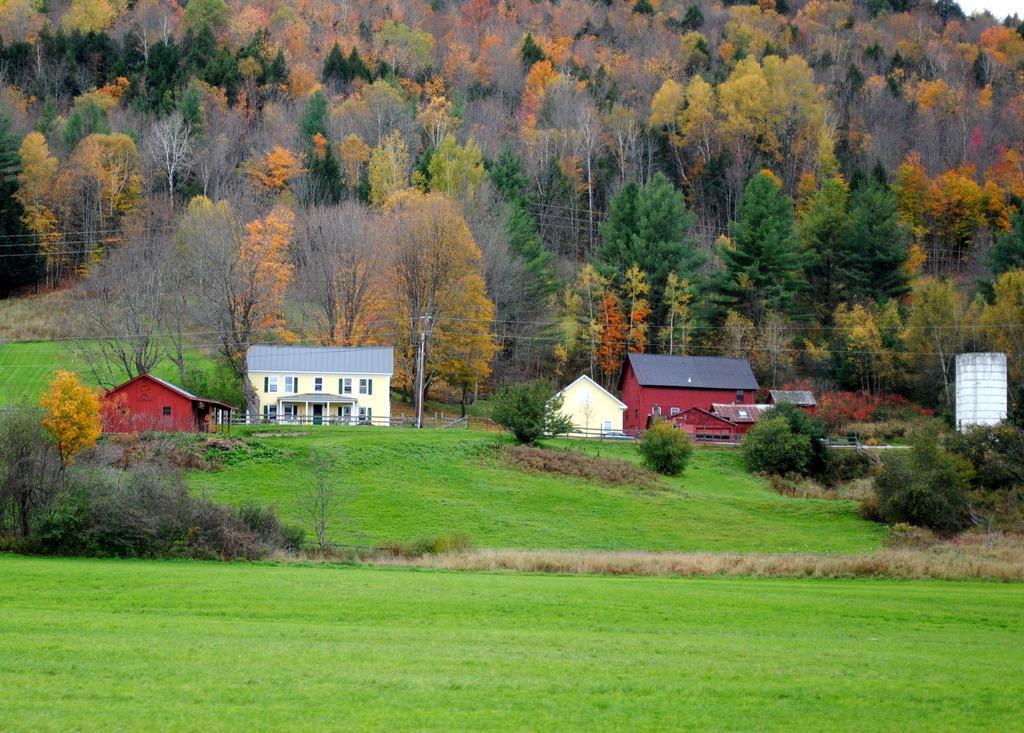Describe this image in one or two sentences. In this picture we can see grass at the bottom, in the background we can see some houses and trees, there is a pole and wires in the middle. 